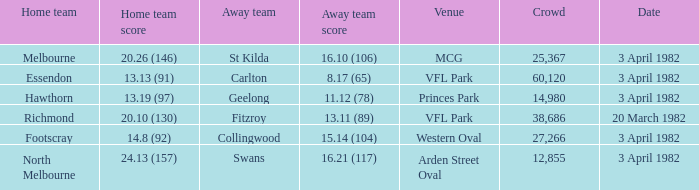When the away team scored 11.12 (78), what was the date of the game? 3 April 1982. 